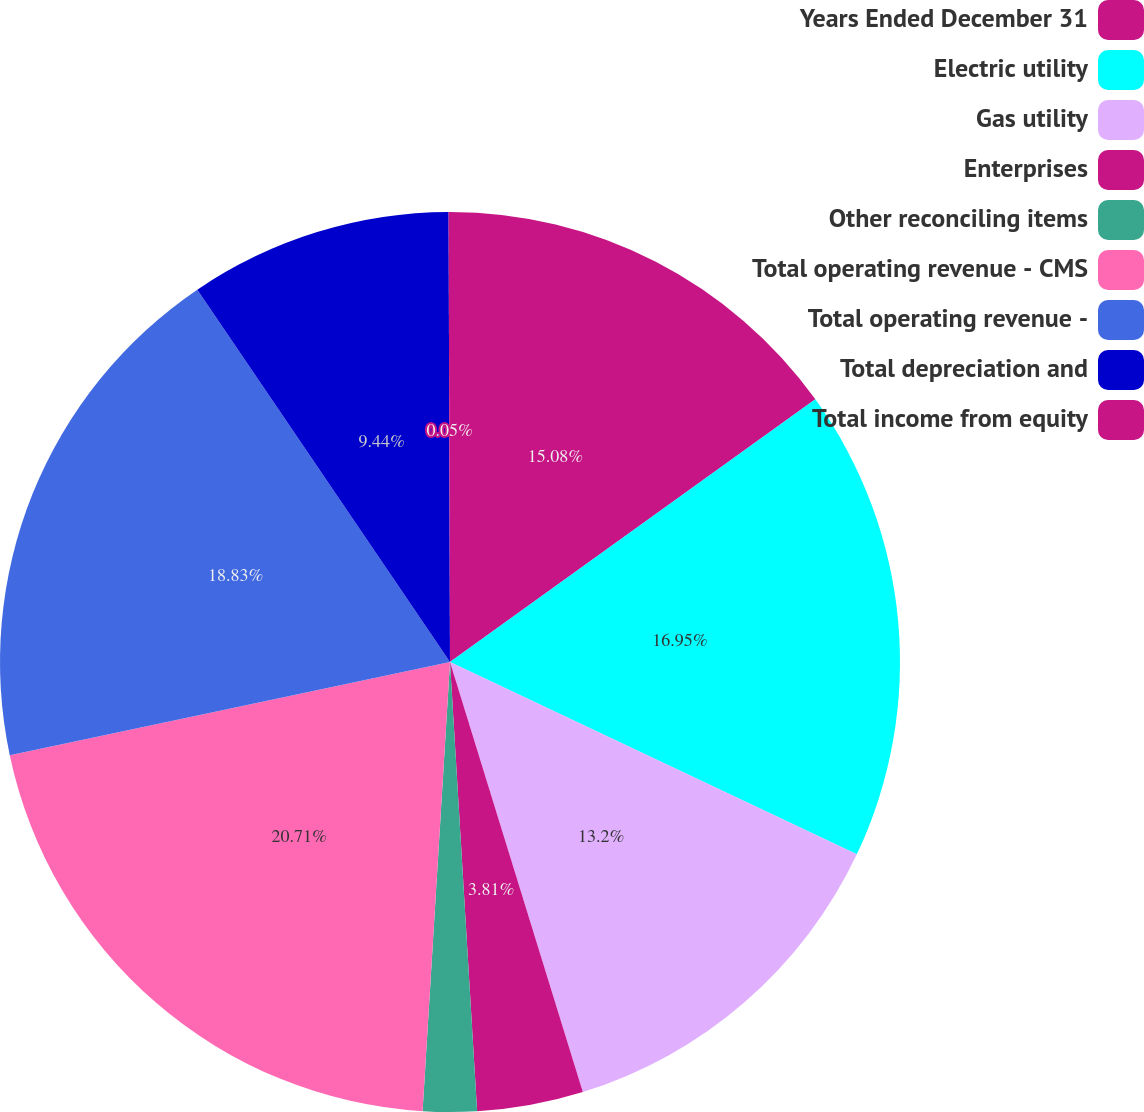<chart> <loc_0><loc_0><loc_500><loc_500><pie_chart><fcel>Years Ended December 31<fcel>Electric utility<fcel>Gas utility<fcel>Enterprises<fcel>Other reconciling items<fcel>Total operating revenue - CMS<fcel>Total operating revenue -<fcel>Total depreciation and<fcel>Total income from equity<nl><fcel>15.08%<fcel>16.95%<fcel>13.2%<fcel>3.81%<fcel>1.93%<fcel>20.71%<fcel>18.83%<fcel>9.44%<fcel>0.05%<nl></chart> 